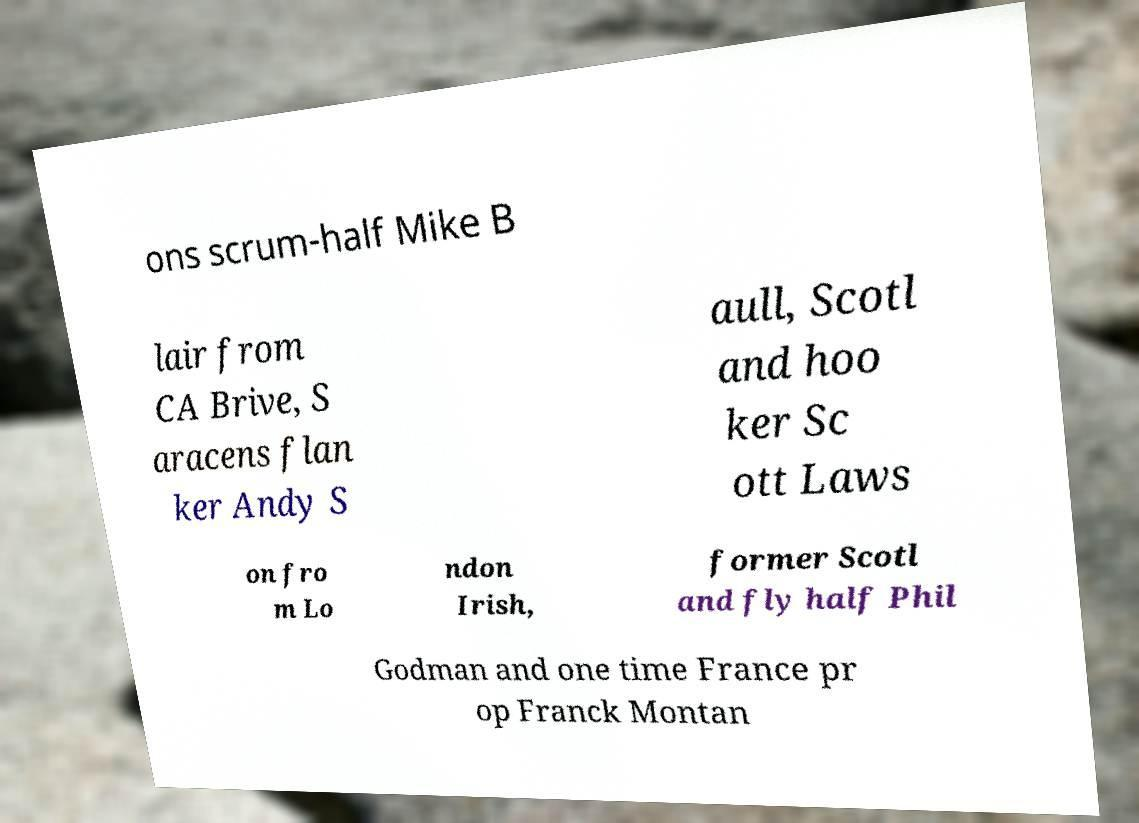There's text embedded in this image that I need extracted. Can you transcribe it verbatim? ons scrum-half Mike B lair from CA Brive, S aracens flan ker Andy S aull, Scotl and hoo ker Sc ott Laws on fro m Lo ndon Irish, former Scotl and fly half Phil Godman and one time France pr op Franck Montan 